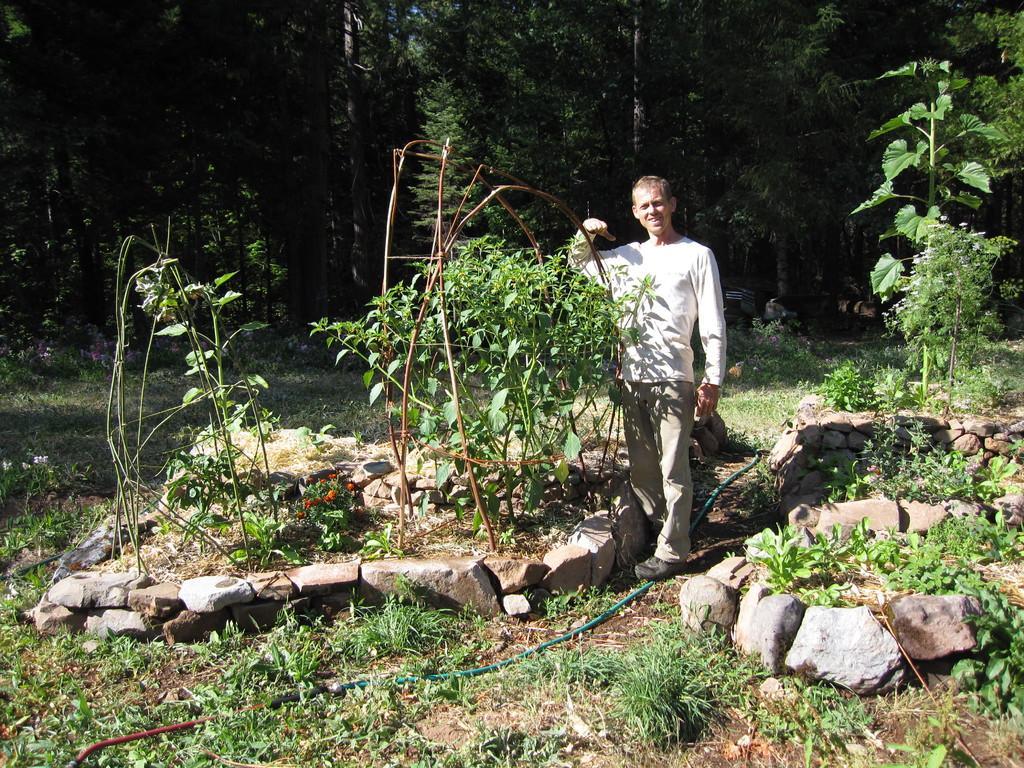Please provide a concise description of this image. In this picture there is a person standing. At the back there are trees. At the bottom there are stones and plants and flowers and there is a pipe and there is grass and mud. 